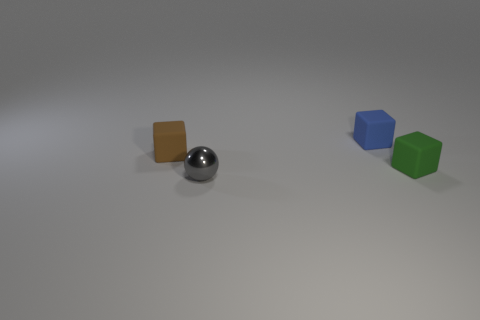Subtract all blue rubber blocks. How many blocks are left? 2 Add 1 small matte balls. How many objects exist? 5 Subtract all brown cubes. How many cubes are left? 2 Subtract all balls. How many objects are left? 3 Subtract 0 brown cylinders. How many objects are left? 4 Subtract 2 blocks. How many blocks are left? 1 Subtract all red blocks. Subtract all brown spheres. How many blocks are left? 3 Subtract all gray balls. Subtract all gray metallic spheres. How many objects are left? 2 Add 1 brown rubber things. How many brown rubber things are left? 2 Add 2 tiny gray balls. How many tiny gray balls exist? 3 